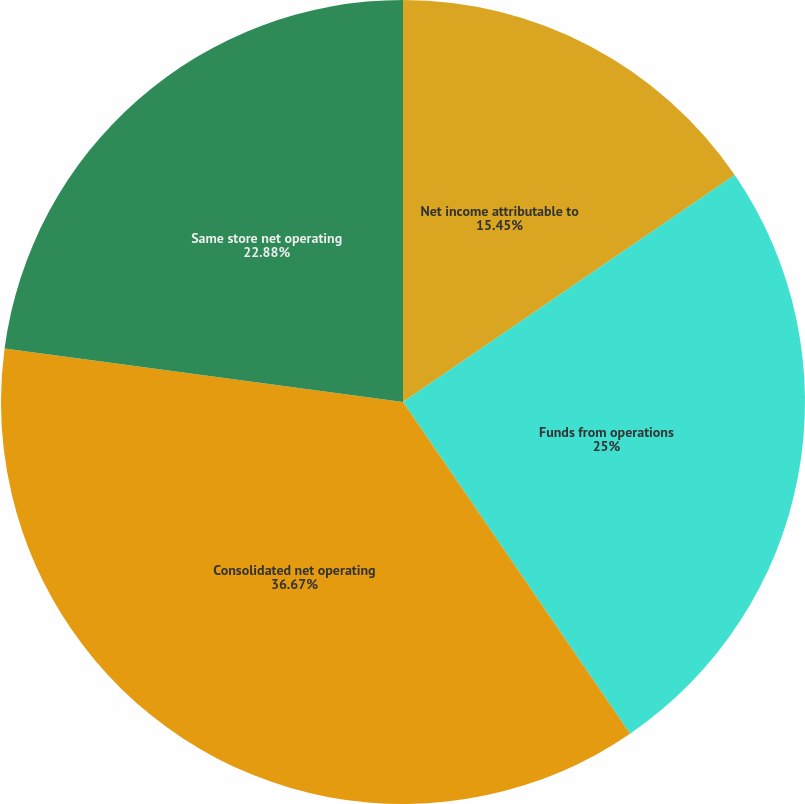Convert chart. <chart><loc_0><loc_0><loc_500><loc_500><pie_chart><fcel>Net income attributable to<fcel>Funds from operations<fcel>Consolidated net operating<fcel>Same store net operating<nl><fcel>15.45%<fcel>25.0%<fcel>36.68%<fcel>22.88%<nl></chart> 